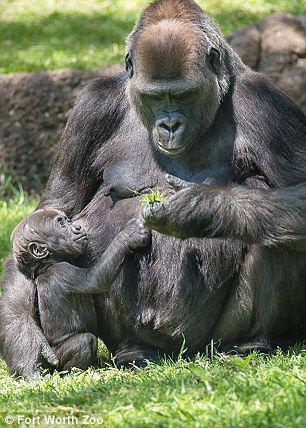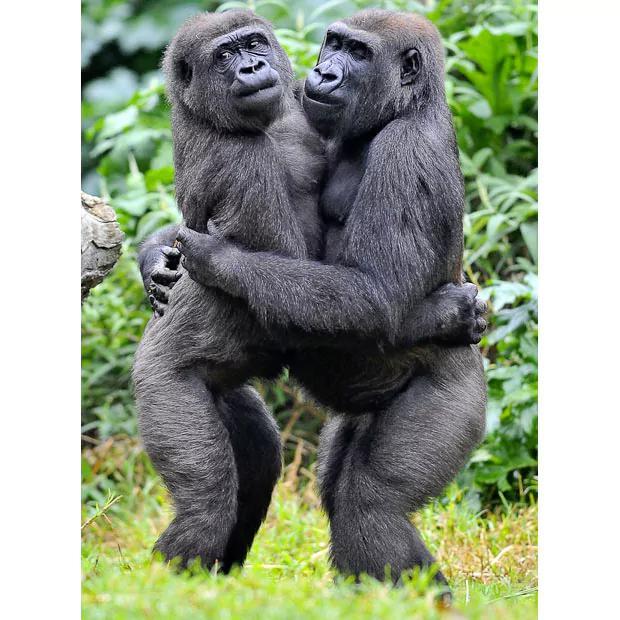The first image is the image on the left, the second image is the image on the right. Evaluate the accuracy of this statement regarding the images: "Left image shows a baby gorilla positioned in front of a sitting adult.". Is it true? Answer yes or no. Yes. The first image is the image on the left, the second image is the image on the right. For the images displayed, is the sentence "There is one small, baby gorilla being carried by its mother." factually correct? Answer yes or no. No. 